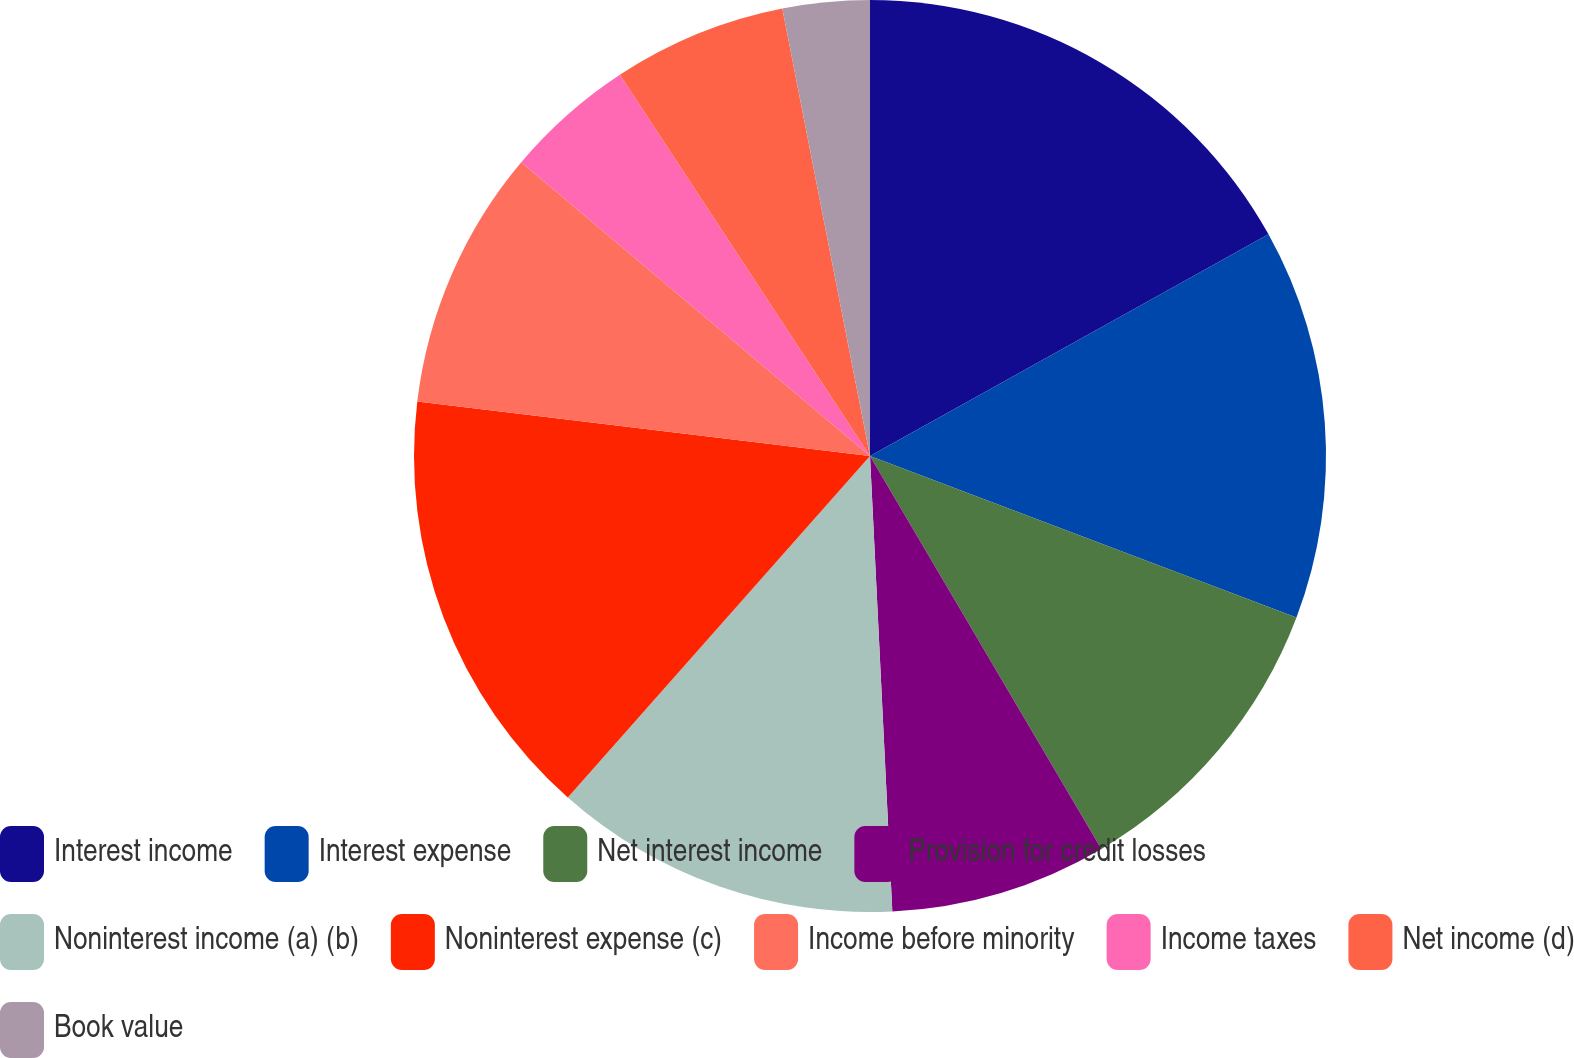Convert chart. <chart><loc_0><loc_0><loc_500><loc_500><pie_chart><fcel>Interest income<fcel>Interest expense<fcel>Net interest income<fcel>Provision for credit losses<fcel>Noninterest income (a) (b)<fcel>Noninterest expense (c)<fcel>Income before minority<fcel>Income taxes<fcel>Net income (d)<fcel>Book value<nl><fcel>16.92%<fcel>13.84%<fcel>10.77%<fcel>7.69%<fcel>12.31%<fcel>15.38%<fcel>9.23%<fcel>4.62%<fcel>6.16%<fcel>3.08%<nl></chart> 